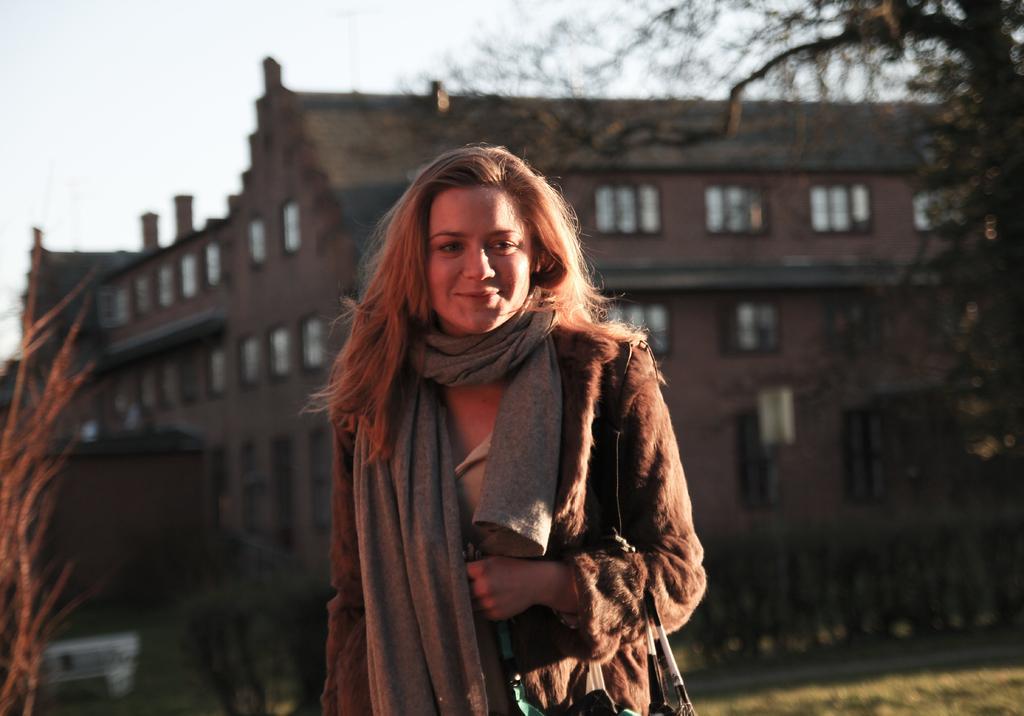In one or two sentences, can you explain what this image depicts? In this picture I can see a person with a smile. I can see trees on the right side. I can see the building in the background. 